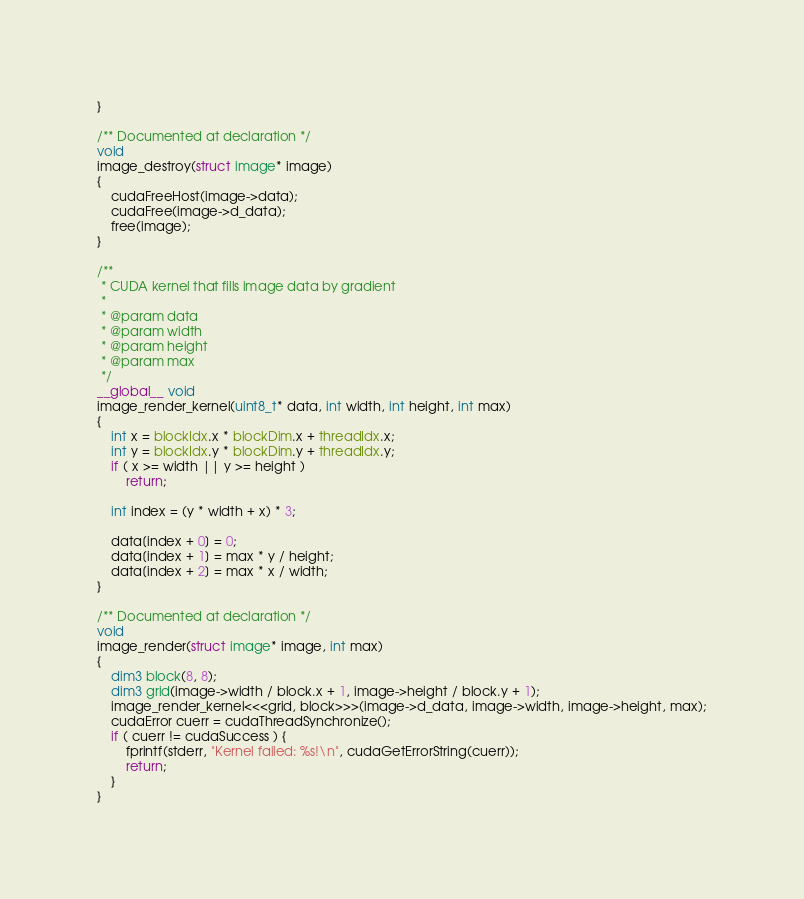Convert code to text. <code><loc_0><loc_0><loc_500><loc_500><_Cuda_>}

/** Documented at declaration */
void
image_destroy(struct image* image)
{
    cudaFreeHost(image->data);
    cudaFree(image->d_data);
    free(image);
}

/**
 * CUDA kernel that fills image data by gradient
 * 
 * @param data
 * @param width
 * @param height
 * @param max
 */
__global__ void
image_render_kernel(uint8_t* data, int width, int height, int max)
{
    int x = blockIdx.x * blockDim.x + threadIdx.x;
    int y = blockIdx.y * blockDim.y + threadIdx.y;
    if ( x >= width || y >= height )
        return;
        
    int index = (y * width + x) * 3;
    
    data[index + 0] = 0;
    data[index + 1] = max * y / height;
    data[index + 2] = max * x / width;
}

/** Documented at declaration */
void
image_render(struct image* image, int max)
{        
    dim3 block(8, 8);
    dim3 grid(image->width / block.x + 1, image->height / block.y + 1);
    image_render_kernel<<<grid, block>>>(image->d_data, image->width, image->height, max);
    cudaError cuerr = cudaThreadSynchronize();
    if ( cuerr != cudaSuccess ) {
        fprintf(stderr, "Kernel failed: %s!\n", cudaGetErrorString(cuerr));
        return;
    }
}
</code> 